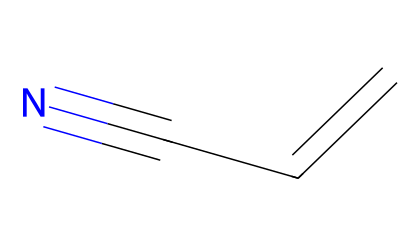What is the name of this chemical? The provided SMILES representation depicts a molecule that consists of a vinyl group (C=CH2) and a nitrile group (C#N). Therefore, the name of the chemical is derived from its structure, which is known as acrylonitrile.
Answer: acrylonitrile How many carbon atoms are present in this chemical? By analyzing the SMILES structure, we see there are three carbon atoms: two are in the vinyl part (C=CH2) and one in the nitrile part (C#N). Thus, the total count is three.
Answer: three What type of functional group is present in acrylonitrile? The molecule contains a nitrile functional group, characterized by the presence of a carbon atom triple-bonded to a nitrogen atom (C#N). This indicates the specific type of group it possesses.
Answer: nitrile What is the total number of double bonds in the chemical structure? In the given structure, there is one double bond present between the two carbons in the vinyl group (C=CH2). Hence, the total count of double bonds is one.
Answer: one What role does acrylonitrile play in plastic manufacturing? Acrylonitrile is primarily used as a precursor in the production of various polymers, especially polyacrylonitrile, which is important in making specialty plastics and fibers as well.
Answer: precursor Is acrylonitrile soluble in water? Generally, acrylonitrile is known to have limited solubility in water due to its hydrophobic characteristics associated with the carbon-carbon bonding; thus it typically does not dissolve well.
Answer: limited solubility 